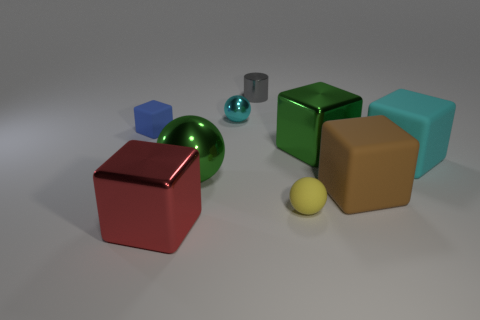Subtract all green blocks. How many blocks are left? 4 Subtract all small blue cubes. How many cubes are left? 4 Subtract all blue blocks. Subtract all cyan cylinders. How many blocks are left? 4 Add 1 red objects. How many objects exist? 10 Subtract all blocks. How many objects are left? 4 Add 3 big red blocks. How many big red blocks are left? 4 Add 7 shiny cubes. How many shiny cubes exist? 9 Subtract 0 gray cubes. How many objects are left? 9 Subtract all large spheres. Subtract all gray metallic things. How many objects are left? 7 